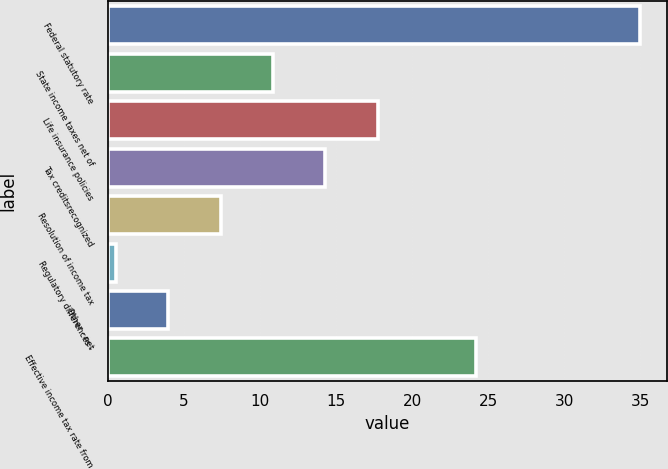Convert chart to OTSL. <chart><loc_0><loc_0><loc_500><loc_500><bar_chart><fcel>Federal statutory rate<fcel>State income taxes net of<fcel>Life insurance policies<fcel>Tax creditsrecognized<fcel>Resolution of income tax<fcel>Regulatory differences -<fcel>Other - net<fcel>Effective income tax rate from<nl><fcel>35<fcel>10.85<fcel>17.75<fcel>14.3<fcel>7.4<fcel>0.5<fcel>3.95<fcel>24.2<nl></chart> 